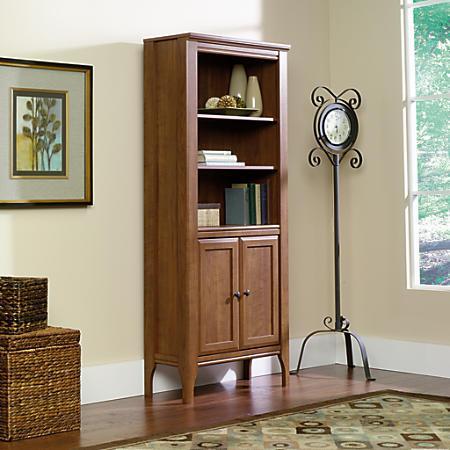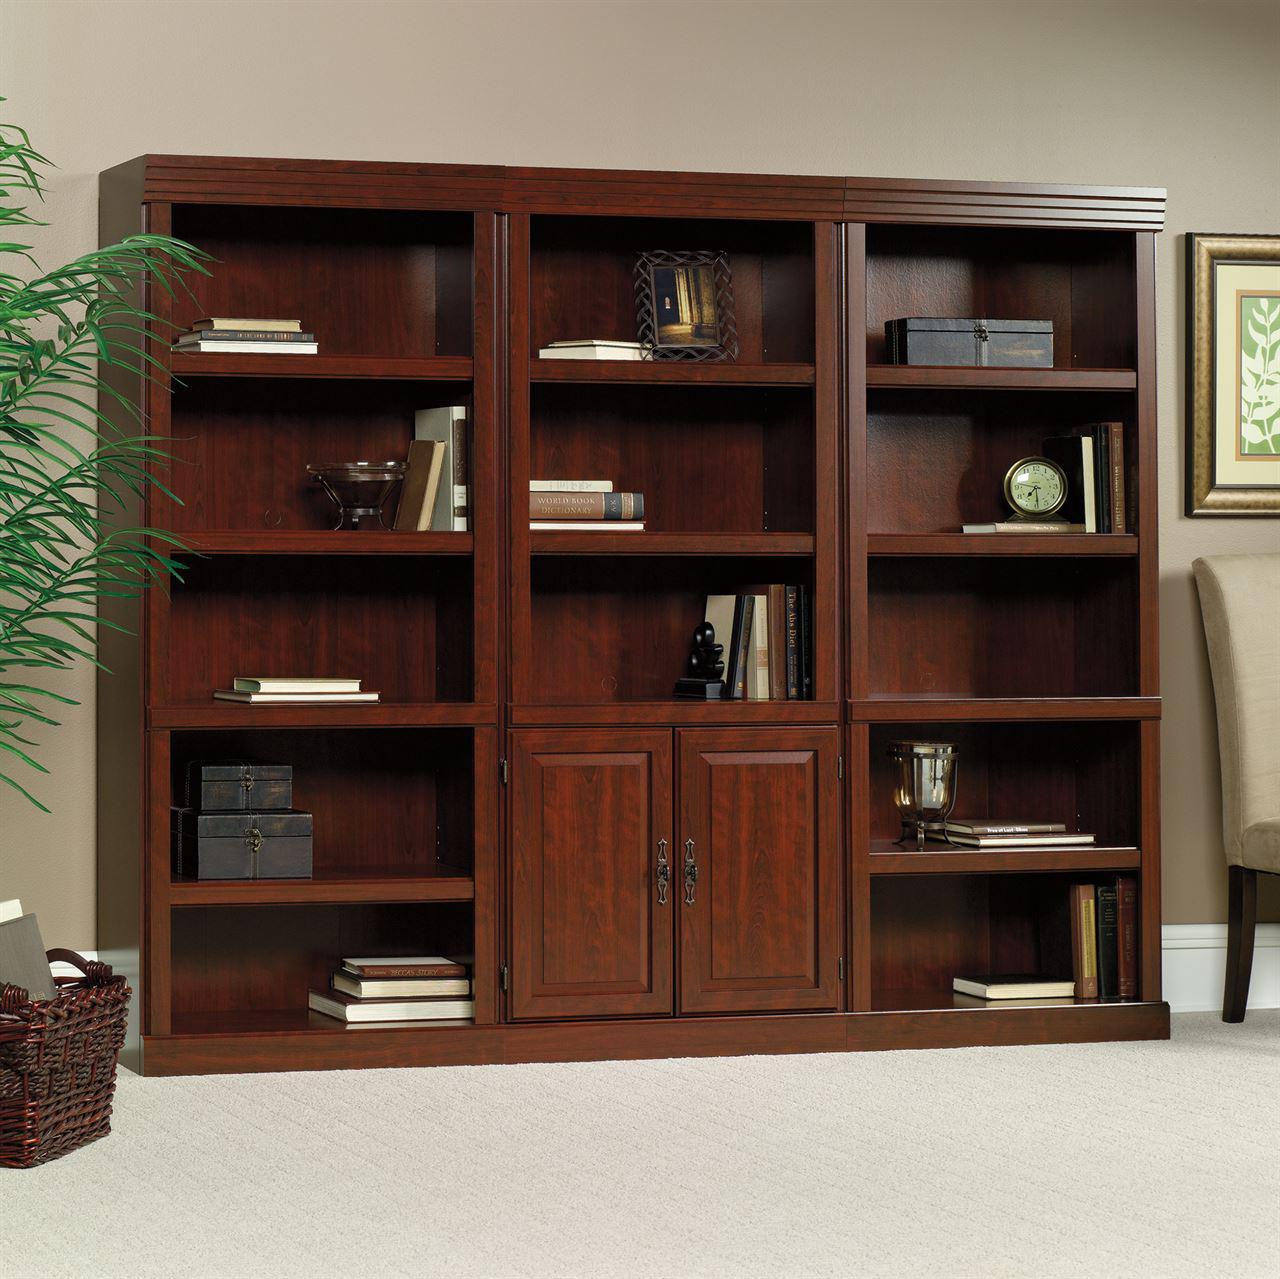The first image is the image on the left, the second image is the image on the right. For the images shown, is this caption "There is one skinny bookshelf in the right image and one larger bookshelf in the left image." true? Answer yes or no. No. The first image is the image on the left, the second image is the image on the right. Evaluate the accuracy of this statement regarding the images: "In at least one image, there is a window with a curtain to the left of a bookcase.". Is it true? Answer yes or no. No. 